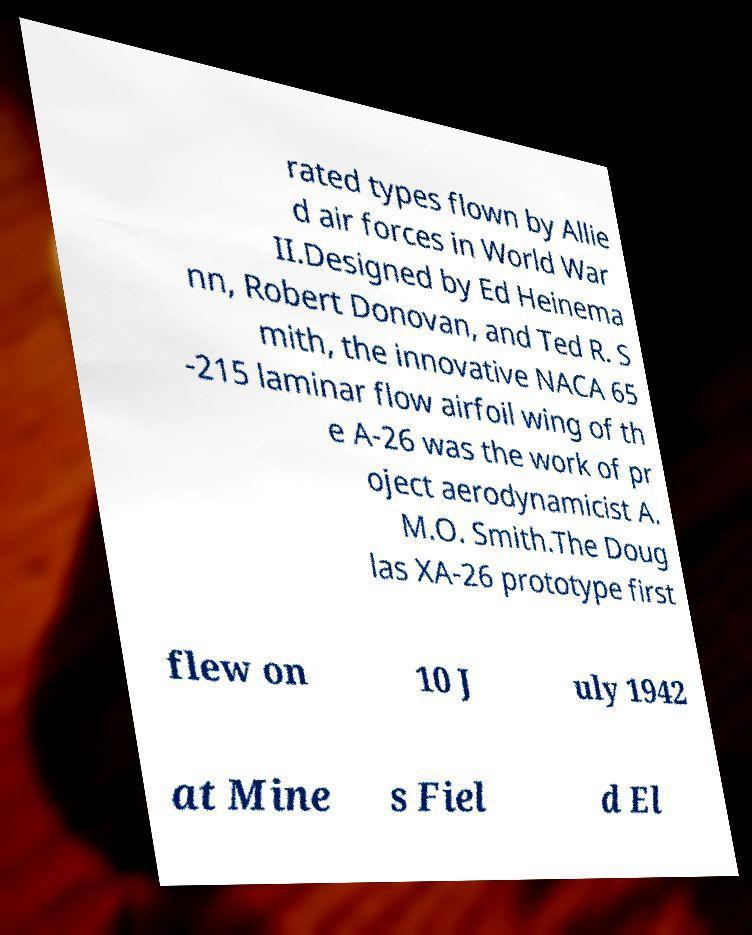Please identify and transcribe the text found in this image. rated types flown by Allie d air forces in World War II.Designed by Ed Heinema nn, Robert Donovan, and Ted R. S mith, the innovative NACA 65 -215 laminar flow airfoil wing of th e A-26 was the work of pr oject aerodynamicist A. M.O. Smith.The Doug las XA-26 prototype first flew on 10 J uly 1942 at Mine s Fiel d El 